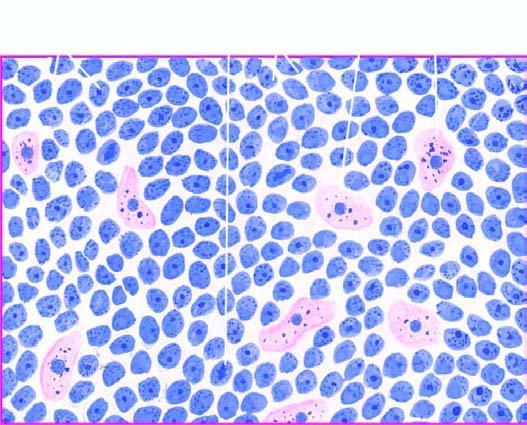does the tumour show uniform cells having high mitotic rate?
Answer the question using a single word or phrase. Yes 